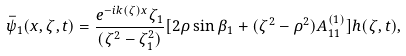Convert formula to latex. <formula><loc_0><loc_0><loc_500><loc_500>\bar { \psi } _ { 1 } ( x , \zeta , t ) = \frac { e ^ { - i k ( \zeta ) x } \zeta _ { 1 } } { ( \zeta ^ { 2 } - \zeta _ { 1 } ^ { 2 } ) } [ 2 \rho \sin \beta _ { 1 } + ( \zeta ^ { 2 } - \rho ^ { 2 } ) A _ { 1 1 } ^ { ( 1 ) } ] h ( \zeta , t ) ,</formula> 